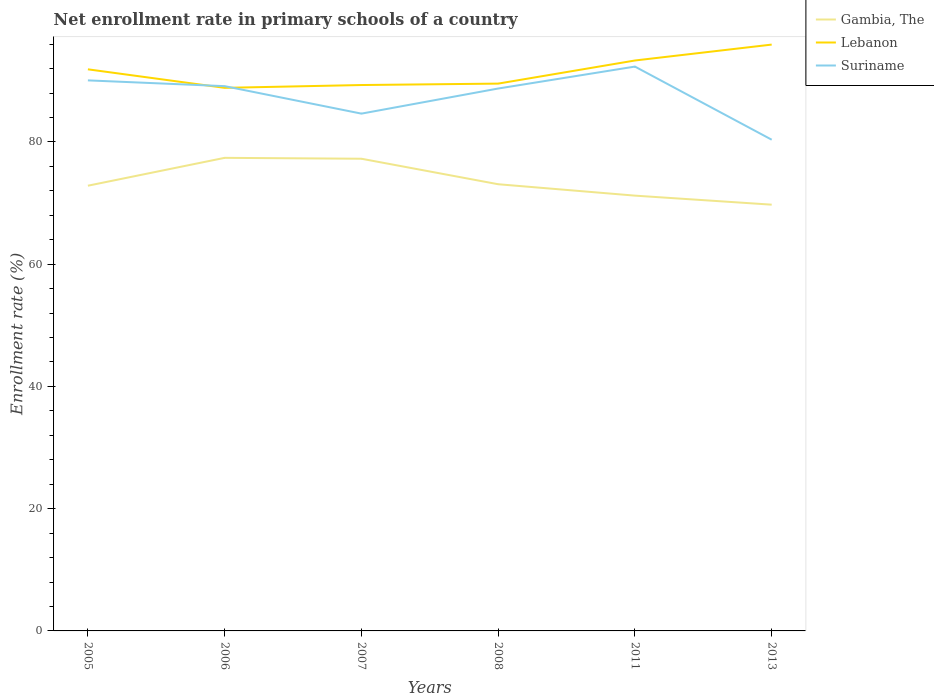Does the line corresponding to Lebanon intersect with the line corresponding to Gambia, The?
Provide a succinct answer. No. Across all years, what is the maximum enrollment rate in primary schools in Gambia, The?
Provide a short and direct response. 69.74. In which year was the enrollment rate in primary schools in Suriname maximum?
Ensure brevity in your answer.  2013. What is the total enrollment rate in primary schools in Lebanon in the graph?
Provide a succinct answer. -0.46. What is the difference between the highest and the second highest enrollment rate in primary schools in Suriname?
Give a very brief answer. 11.96. What is the difference between the highest and the lowest enrollment rate in primary schools in Lebanon?
Provide a short and direct response. 3. Is the enrollment rate in primary schools in Lebanon strictly greater than the enrollment rate in primary schools in Gambia, The over the years?
Give a very brief answer. No. How many lines are there?
Provide a short and direct response. 3. How many years are there in the graph?
Provide a succinct answer. 6. Are the values on the major ticks of Y-axis written in scientific E-notation?
Your answer should be compact. No. Does the graph contain any zero values?
Provide a short and direct response. No. Where does the legend appear in the graph?
Offer a terse response. Top right. How many legend labels are there?
Your answer should be very brief. 3. What is the title of the graph?
Make the answer very short. Net enrollment rate in primary schools of a country. Does "Suriname" appear as one of the legend labels in the graph?
Make the answer very short. Yes. What is the label or title of the X-axis?
Offer a very short reply. Years. What is the label or title of the Y-axis?
Make the answer very short. Enrollment rate (%). What is the Enrollment rate (%) of Gambia, The in 2005?
Offer a very short reply. 72.84. What is the Enrollment rate (%) in Lebanon in 2005?
Your answer should be very brief. 91.88. What is the Enrollment rate (%) of Suriname in 2005?
Provide a short and direct response. 90.07. What is the Enrollment rate (%) in Gambia, The in 2006?
Provide a short and direct response. 77.4. What is the Enrollment rate (%) in Lebanon in 2006?
Your response must be concise. 88.85. What is the Enrollment rate (%) of Suriname in 2006?
Your answer should be compact. 89.13. What is the Enrollment rate (%) in Gambia, The in 2007?
Ensure brevity in your answer.  77.25. What is the Enrollment rate (%) in Lebanon in 2007?
Provide a short and direct response. 89.31. What is the Enrollment rate (%) in Suriname in 2007?
Offer a very short reply. 84.63. What is the Enrollment rate (%) of Gambia, The in 2008?
Ensure brevity in your answer.  73.08. What is the Enrollment rate (%) in Lebanon in 2008?
Your response must be concise. 89.54. What is the Enrollment rate (%) of Suriname in 2008?
Provide a succinct answer. 88.74. What is the Enrollment rate (%) of Gambia, The in 2011?
Offer a terse response. 71.21. What is the Enrollment rate (%) of Lebanon in 2011?
Your response must be concise. 93.32. What is the Enrollment rate (%) in Suriname in 2011?
Make the answer very short. 92.33. What is the Enrollment rate (%) in Gambia, The in 2013?
Keep it short and to the point. 69.74. What is the Enrollment rate (%) of Lebanon in 2013?
Keep it short and to the point. 95.93. What is the Enrollment rate (%) of Suriname in 2013?
Offer a very short reply. 80.36. Across all years, what is the maximum Enrollment rate (%) of Gambia, The?
Offer a very short reply. 77.4. Across all years, what is the maximum Enrollment rate (%) of Lebanon?
Offer a terse response. 95.93. Across all years, what is the maximum Enrollment rate (%) in Suriname?
Ensure brevity in your answer.  92.33. Across all years, what is the minimum Enrollment rate (%) of Gambia, The?
Provide a short and direct response. 69.74. Across all years, what is the minimum Enrollment rate (%) of Lebanon?
Your answer should be compact. 88.85. Across all years, what is the minimum Enrollment rate (%) in Suriname?
Provide a short and direct response. 80.36. What is the total Enrollment rate (%) in Gambia, The in the graph?
Provide a succinct answer. 441.52. What is the total Enrollment rate (%) in Lebanon in the graph?
Offer a very short reply. 548.83. What is the total Enrollment rate (%) of Suriname in the graph?
Offer a very short reply. 525.26. What is the difference between the Enrollment rate (%) in Gambia, The in 2005 and that in 2006?
Offer a very short reply. -4.56. What is the difference between the Enrollment rate (%) of Lebanon in 2005 and that in 2006?
Keep it short and to the point. 3.03. What is the difference between the Enrollment rate (%) of Suriname in 2005 and that in 2006?
Your answer should be very brief. 0.95. What is the difference between the Enrollment rate (%) in Gambia, The in 2005 and that in 2007?
Make the answer very short. -4.41. What is the difference between the Enrollment rate (%) of Lebanon in 2005 and that in 2007?
Provide a short and direct response. 2.57. What is the difference between the Enrollment rate (%) of Suriname in 2005 and that in 2007?
Your response must be concise. 5.44. What is the difference between the Enrollment rate (%) of Gambia, The in 2005 and that in 2008?
Provide a short and direct response. -0.24. What is the difference between the Enrollment rate (%) in Lebanon in 2005 and that in 2008?
Provide a short and direct response. 2.34. What is the difference between the Enrollment rate (%) of Suriname in 2005 and that in 2008?
Your answer should be very brief. 1.33. What is the difference between the Enrollment rate (%) of Gambia, The in 2005 and that in 2011?
Your answer should be very brief. 1.62. What is the difference between the Enrollment rate (%) of Lebanon in 2005 and that in 2011?
Your answer should be very brief. -1.44. What is the difference between the Enrollment rate (%) in Suriname in 2005 and that in 2011?
Keep it short and to the point. -2.26. What is the difference between the Enrollment rate (%) in Gambia, The in 2005 and that in 2013?
Provide a short and direct response. 3.1. What is the difference between the Enrollment rate (%) in Lebanon in 2005 and that in 2013?
Your answer should be very brief. -4.05. What is the difference between the Enrollment rate (%) in Suriname in 2005 and that in 2013?
Offer a terse response. 9.71. What is the difference between the Enrollment rate (%) of Gambia, The in 2006 and that in 2007?
Provide a succinct answer. 0.14. What is the difference between the Enrollment rate (%) of Lebanon in 2006 and that in 2007?
Your answer should be very brief. -0.46. What is the difference between the Enrollment rate (%) in Suriname in 2006 and that in 2007?
Provide a short and direct response. 4.49. What is the difference between the Enrollment rate (%) in Gambia, The in 2006 and that in 2008?
Keep it short and to the point. 4.32. What is the difference between the Enrollment rate (%) of Lebanon in 2006 and that in 2008?
Your answer should be very brief. -0.69. What is the difference between the Enrollment rate (%) of Suriname in 2006 and that in 2008?
Make the answer very short. 0.39. What is the difference between the Enrollment rate (%) of Gambia, The in 2006 and that in 2011?
Give a very brief answer. 6.18. What is the difference between the Enrollment rate (%) of Lebanon in 2006 and that in 2011?
Keep it short and to the point. -4.47. What is the difference between the Enrollment rate (%) in Suriname in 2006 and that in 2011?
Your answer should be very brief. -3.2. What is the difference between the Enrollment rate (%) in Gambia, The in 2006 and that in 2013?
Provide a short and direct response. 7.66. What is the difference between the Enrollment rate (%) of Lebanon in 2006 and that in 2013?
Make the answer very short. -7.08. What is the difference between the Enrollment rate (%) of Suriname in 2006 and that in 2013?
Keep it short and to the point. 8.76. What is the difference between the Enrollment rate (%) in Gambia, The in 2007 and that in 2008?
Give a very brief answer. 4.17. What is the difference between the Enrollment rate (%) of Lebanon in 2007 and that in 2008?
Keep it short and to the point. -0.23. What is the difference between the Enrollment rate (%) of Suriname in 2007 and that in 2008?
Give a very brief answer. -4.11. What is the difference between the Enrollment rate (%) in Gambia, The in 2007 and that in 2011?
Make the answer very short. 6.04. What is the difference between the Enrollment rate (%) in Lebanon in 2007 and that in 2011?
Offer a terse response. -4.01. What is the difference between the Enrollment rate (%) of Suriname in 2007 and that in 2011?
Offer a terse response. -7.7. What is the difference between the Enrollment rate (%) of Gambia, The in 2007 and that in 2013?
Give a very brief answer. 7.52. What is the difference between the Enrollment rate (%) in Lebanon in 2007 and that in 2013?
Your response must be concise. -6.62. What is the difference between the Enrollment rate (%) in Suriname in 2007 and that in 2013?
Make the answer very short. 4.27. What is the difference between the Enrollment rate (%) of Gambia, The in 2008 and that in 2011?
Provide a succinct answer. 1.86. What is the difference between the Enrollment rate (%) in Lebanon in 2008 and that in 2011?
Make the answer very short. -3.78. What is the difference between the Enrollment rate (%) of Suriname in 2008 and that in 2011?
Your answer should be very brief. -3.59. What is the difference between the Enrollment rate (%) in Gambia, The in 2008 and that in 2013?
Provide a short and direct response. 3.34. What is the difference between the Enrollment rate (%) of Lebanon in 2008 and that in 2013?
Your answer should be compact. -6.39. What is the difference between the Enrollment rate (%) of Suriname in 2008 and that in 2013?
Provide a succinct answer. 8.37. What is the difference between the Enrollment rate (%) in Gambia, The in 2011 and that in 2013?
Your response must be concise. 1.48. What is the difference between the Enrollment rate (%) in Lebanon in 2011 and that in 2013?
Give a very brief answer. -2.6. What is the difference between the Enrollment rate (%) of Suriname in 2011 and that in 2013?
Ensure brevity in your answer.  11.96. What is the difference between the Enrollment rate (%) of Gambia, The in 2005 and the Enrollment rate (%) of Lebanon in 2006?
Offer a terse response. -16.01. What is the difference between the Enrollment rate (%) of Gambia, The in 2005 and the Enrollment rate (%) of Suriname in 2006?
Give a very brief answer. -16.29. What is the difference between the Enrollment rate (%) of Lebanon in 2005 and the Enrollment rate (%) of Suriname in 2006?
Provide a short and direct response. 2.75. What is the difference between the Enrollment rate (%) of Gambia, The in 2005 and the Enrollment rate (%) of Lebanon in 2007?
Your answer should be very brief. -16.47. What is the difference between the Enrollment rate (%) of Gambia, The in 2005 and the Enrollment rate (%) of Suriname in 2007?
Your answer should be very brief. -11.79. What is the difference between the Enrollment rate (%) in Lebanon in 2005 and the Enrollment rate (%) in Suriname in 2007?
Offer a terse response. 7.25. What is the difference between the Enrollment rate (%) in Gambia, The in 2005 and the Enrollment rate (%) in Lebanon in 2008?
Your answer should be very brief. -16.7. What is the difference between the Enrollment rate (%) of Gambia, The in 2005 and the Enrollment rate (%) of Suriname in 2008?
Ensure brevity in your answer.  -15.9. What is the difference between the Enrollment rate (%) in Lebanon in 2005 and the Enrollment rate (%) in Suriname in 2008?
Make the answer very short. 3.14. What is the difference between the Enrollment rate (%) in Gambia, The in 2005 and the Enrollment rate (%) in Lebanon in 2011?
Give a very brief answer. -20.48. What is the difference between the Enrollment rate (%) in Gambia, The in 2005 and the Enrollment rate (%) in Suriname in 2011?
Provide a short and direct response. -19.49. What is the difference between the Enrollment rate (%) in Lebanon in 2005 and the Enrollment rate (%) in Suriname in 2011?
Give a very brief answer. -0.45. What is the difference between the Enrollment rate (%) of Gambia, The in 2005 and the Enrollment rate (%) of Lebanon in 2013?
Offer a very short reply. -23.09. What is the difference between the Enrollment rate (%) in Gambia, The in 2005 and the Enrollment rate (%) in Suriname in 2013?
Provide a short and direct response. -7.53. What is the difference between the Enrollment rate (%) of Lebanon in 2005 and the Enrollment rate (%) of Suriname in 2013?
Offer a very short reply. 11.52. What is the difference between the Enrollment rate (%) of Gambia, The in 2006 and the Enrollment rate (%) of Lebanon in 2007?
Provide a short and direct response. -11.91. What is the difference between the Enrollment rate (%) in Gambia, The in 2006 and the Enrollment rate (%) in Suriname in 2007?
Your answer should be compact. -7.23. What is the difference between the Enrollment rate (%) of Lebanon in 2006 and the Enrollment rate (%) of Suriname in 2007?
Your answer should be very brief. 4.22. What is the difference between the Enrollment rate (%) in Gambia, The in 2006 and the Enrollment rate (%) in Lebanon in 2008?
Your response must be concise. -12.15. What is the difference between the Enrollment rate (%) of Gambia, The in 2006 and the Enrollment rate (%) of Suriname in 2008?
Offer a terse response. -11.34. What is the difference between the Enrollment rate (%) in Lebanon in 2006 and the Enrollment rate (%) in Suriname in 2008?
Your response must be concise. 0.11. What is the difference between the Enrollment rate (%) of Gambia, The in 2006 and the Enrollment rate (%) of Lebanon in 2011?
Give a very brief answer. -15.93. What is the difference between the Enrollment rate (%) in Gambia, The in 2006 and the Enrollment rate (%) in Suriname in 2011?
Give a very brief answer. -14.93. What is the difference between the Enrollment rate (%) in Lebanon in 2006 and the Enrollment rate (%) in Suriname in 2011?
Make the answer very short. -3.48. What is the difference between the Enrollment rate (%) of Gambia, The in 2006 and the Enrollment rate (%) of Lebanon in 2013?
Your answer should be compact. -18.53. What is the difference between the Enrollment rate (%) in Gambia, The in 2006 and the Enrollment rate (%) in Suriname in 2013?
Offer a terse response. -2.97. What is the difference between the Enrollment rate (%) in Lebanon in 2006 and the Enrollment rate (%) in Suriname in 2013?
Your answer should be compact. 8.48. What is the difference between the Enrollment rate (%) in Gambia, The in 2007 and the Enrollment rate (%) in Lebanon in 2008?
Offer a terse response. -12.29. What is the difference between the Enrollment rate (%) in Gambia, The in 2007 and the Enrollment rate (%) in Suriname in 2008?
Offer a terse response. -11.49. What is the difference between the Enrollment rate (%) in Lebanon in 2007 and the Enrollment rate (%) in Suriname in 2008?
Your answer should be very brief. 0.57. What is the difference between the Enrollment rate (%) in Gambia, The in 2007 and the Enrollment rate (%) in Lebanon in 2011?
Provide a succinct answer. -16.07. What is the difference between the Enrollment rate (%) of Gambia, The in 2007 and the Enrollment rate (%) of Suriname in 2011?
Make the answer very short. -15.08. What is the difference between the Enrollment rate (%) in Lebanon in 2007 and the Enrollment rate (%) in Suriname in 2011?
Provide a succinct answer. -3.02. What is the difference between the Enrollment rate (%) of Gambia, The in 2007 and the Enrollment rate (%) of Lebanon in 2013?
Make the answer very short. -18.68. What is the difference between the Enrollment rate (%) of Gambia, The in 2007 and the Enrollment rate (%) of Suriname in 2013?
Your answer should be very brief. -3.11. What is the difference between the Enrollment rate (%) in Lebanon in 2007 and the Enrollment rate (%) in Suriname in 2013?
Make the answer very short. 8.94. What is the difference between the Enrollment rate (%) in Gambia, The in 2008 and the Enrollment rate (%) in Lebanon in 2011?
Provide a succinct answer. -20.24. What is the difference between the Enrollment rate (%) of Gambia, The in 2008 and the Enrollment rate (%) of Suriname in 2011?
Provide a short and direct response. -19.25. What is the difference between the Enrollment rate (%) of Lebanon in 2008 and the Enrollment rate (%) of Suriname in 2011?
Offer a very short reply. -2.79. What is the difference between the Enrollment rate (%) of Gambia, The in 2008 and the Enrollment rate (%) of Lebanon in 2013?
Your response must be concise. -22.85. What is the difference between the Enrollment rate (%) in Gambia, The in 2008 and the Enrollment rate (%) in Suriname in 2013?
Ensure brevity in your answer.  -7.29. What is the difference between the Enrollment rate (%) of Lebanon in 2008 and the Enrollment rate (%) of Suriname in 2013?
Make the answer very short. 9.18. What is the difference between the Enrollment rate (%) of Gambia, The in 2011 and the Enrollment rate (%) of Lebanon in 2013?
Ensure brevity in your answer.  -24.71. What is the difference between the Enrollment rate (%) in Gambia, The in 2011 and the Enrollment rate (%) in Suriname in 2013?
Your answer should be compact. -9.15. What is the difference between the Enrollment rate (%) of Lebanon in 2011 and the Enrollment rate (%) of Suriname in 2013?
Give a very brief answer. 12.96. What is the average Enrollment rate (%) in Gambia, The per year?
Keep it short and to the point. 73.59. What is the average Enrollment rate (%) of Lebanon per year?
Make the answer very short. 91.47. What is the average Enrollment rate (%) of Suriname per year?
Your answer should be compact. 87.54. In the year 2005, what is the difference between the Enrollment rate (%) of Gambia, The and Enrollment rate (%) of Lebanon?
Provide a short and direct response. -19.04. In the year 2005, what is the difference between the Enrollment rate (%) of Gambia, The and Enrollment rate (%) of Suriname?
Keep it short and to the point. -17.23. In the year 2005, what is the difference between the Enrollment rate (%) in Lebanon and Enrollment rate (%) in Suriname?
Your response must be concise. 1.81. In the year 2006, what is the difference between the Enrollment rate (%) of Gambia, The and Enrollment rate (%) of Lebanon?
Offer a very short reply. -11.45. In the year 2006, what is the difference between the Enrollment rate (%) of Gambia, The and Enrollment rate (%) of Suriname?
Provide a succinct answer. -11.73. In the year 2006, what is the difference between the Enrollment rate (%) in Lebanon and Enrollment rate (%) in Suriname?
Your answer should be very brief. -0.28. In the year 2007, what is the difference between the Enrollment rate (%) of Gambia, The and Enrollment rate (%) of Lebanon?
Your answer should be very brief. -12.06. In the year 2007, what is the difference between the Enrollment rate (%) of Gambia, The and Enrollment rate (%) of Suriname?
Provide a short and direct response. -7.38. In the year 2007, what is the difference between the Enrollment rate (%) in Lebanon and Enrollment rate (%) in Suriname?
Your answer should be compact. 4.68. In the year 2008, what is the difference between the Enrollment rate (%) of Gambia, The and Enrollment rate (%) of Lebanon?
Keep it short and to the point. -16.46. In the year 2008, what is the difference between the Enrollment rate (%) of Gambia, The and Enrollment rate (%) of Suriname?
Provide a succinct answer. -15.66. In the year 2008, what is the difference between the Enrollment rate (%) of Lebanon and Enrollment rate (%) of Suriname?
Offer a terse response. 0.8. In the year 2011, what is the difference between the Enrollment rate (%) in Gambia, The and Enrollment rate (%) in Lebanon?
Offer a very short reply. -22.11. In the year 2011, what is the difference between the Enrollment rate (%) in Gambia, The and Enrollment rate (%) in Suriname?
Your answer should be compact. -21.11. In the year 2011, what is the difference between the Enrollment rate (%) of Lebanon and Enrollment rate (%) of Suriname?
Ensure brevity in your answer.  1. In the year 2013, what is the difference between the Enrollment rate (%) of Gambia, The and Enrollment rate (%) of Lebanon?
Provide a short and direct response. -26.19. In the year 2013, what is the difference between the Enrollment rate (%) in Gambia, The and Enrollment rate (%) in Suriname?
Provide a succinct answer. -10.63. In the year 2013, what is the difference between the Enrollment rate (%) in Lebanon and Enrollment rate (%) in Suriname?
Give a very brief answer. 15.56. What is the ratio of the Enrollment rate (%) in Gambia, The in 2005 to that in 2006?
Provide a short and direct response. 0.94. What is the ratio of the Enrollment rate (%) of Lebanon in 2005 to that in 2006?
Provide a short and direct response. 1.03. What is the ratio of the Enrollment rate (%) of Suriname in 2005 to that in 2006?
Ensure brevity in your answer.  1.01. What is the ratio of the Enrollment rate (%) of Gambia, The in 2005 to that in 2007?
Provide a succinct answer. 0.94. What is the ratio of the Enrollment rate (%) in Lebanon in 2005 to that in 2007?
Give a very brief answer. 1.03. What is the ratio of the Enrollment rate (%) of Suriname in 2005 to that in 2007?
Your answer should be very brief. 1.06. What is the ratio of the Enrollment rate (%) of Lebanon in 2005 to that in 2008?
Your answer should be very brief. 1.03. What is the ratio of the Enrollment rate (%) in Suriname in 2005 to that in 2008?
Make the answer very short. 1.01. What is the ratio of the Enrollment rate (%) of Gambia, The in 2005 to that in 2011?
Provide a short and direct response. 1.02. What is the ratio of the Enrollment rate (%) of Lebanon in 2005 to that in 2011?
Keep it short and to the point. 0.98. What is the ratio of the Enrollment rate (%) in Suriname in 2005 to that in 2011?
Make the answer very short. 0.98. What is the ratio of the Enrollment rate (%) in Gambia, The in 2005 to that in 2013?
Keep it short and to the point. 1.04. What is the ratio of the Enrollment rate (%) of Lebanon in 2005 to that in 2013?
Give a very brief answer. 0.96. What is the ratio of the Enrollment rate (%) in Suriname in 2005 to that in 2013?
Your response must be concise. 1.12. What is the ratio of the Enrollment rate (%) of Gambia, The in 2006 to that in 2007?
Provide a short and direct response. 1. What is the ratio of the Enrollment rate (%) in Suriname in 2006 to that in 2007?
Give a very brief answer. 1.05. What is the ratio of the Enrollment rate (%) in Gambia, The in 2006 to that in 2008?
Your response must be concise. 1.06. What is the ratio of the Enrollment rate (%) of Lebanon in 2006 to that in 2008?
Keep it short and to the point. 0.99. What is the ratio of the Enrollment rate (%) in Gambia, The in 2006 to that in 2011?
Make the answer very short. 1.09. What is the ratio of the Enrollment rate (%) in Lebanon in 2006 to that in 2011?
Give a very brief answer. 0.95. What is the ratio of the Enrollment rate (%) of Suriname in 2006 to that in 2011?
Make the answer very short. 0.97. What is the ratio of the Enrollment rate (%) in Gambia, The in 2006 to that in 2013?
Ensure brevity in your answer.  1.11. What is the ratio of the Enrollment rate (%) of Lebanon in 2006 to that in 2013?
Ensure brevity in your answer.  0.93. What is the ratio of the Enrollment rate (%) of Suriname in 2006 to that in 2013?
Provide a short and direct response. 1.11. What is the ratio of the Enrollment rate (%) of Gambia, The in 2007 to that in 2008?
Offer a very short reply. 1.06. What is the ratio of the Enrollment rate (%) in Lebanon in 2007 to that in 2008?
Provide a succinct answer. 1. What is the ratio of the Enrollment rate (%) in Suriname in 2007 to that in 2008?
Your response must be concise. 0.95. What is the ratio of the Enrollment rate (%) in Gambia, The in 2007 to that in 2011?
Ensure brevity in your answer.  1.08. What is the ratio of the Enrollment rate (%) in Lebanon in 2007 to that in 2011?
Ensure brevity in your answer.  0.96. What is the ratio of the Enrollment rate (%) in Suriname in 2007 to that in 2011?
Provide a short and direct response. 0.92. What is the ratio of the Enrollment rate (%) of Gambia, The in 2007 to that in 2013?
Provide a short and direct response. 1.11. What is the ratio of the Enrollment rate (%) of Suriname in 2007 to that in 2013?
Offer a very short reply. 1.05. What is the ratio of the Enrollment rate (%) of Gambia, The in 2008 to that in 2011?
Your answer should be compact. 1.03. What is the ratio of the Enrollment rate (%) in Lebanon in 2008 to that in 2011?
Your answer should be very brief. 0.96. What is the ratio of the Enrollment rate (%) in Suriname in 2008 to that in 2011?
Your answer should be very brief. 0.96. What is the ratio of the Enrollment rate (%) of Gambia, The in 2008 to that in 2013?
Ensure brevity in your answer.  1.05. What is the ratio of the Enrollment rate (%) in Lebanon in 2008 to that in 2013?
Your response must be concise. 0.93. What is the ratio of the Enrollment rate (%) of Suriname in 2008 to that in 2013?
Your answer should be compact. 1.1. What is the ratio of the Enrollment rate (%) of Gambia, The in 2011 to that in 2013?
Offer a very short reply. 1.02. What is the ratio of the Enrollment rate (%) in Lebanon in 2011 to that in 2013?
Keep it short and to the point. 0.97. What is the ratio of the Enrollment rate (%) in Suriname in 2011 to that in 2013?
Make the answer very short. 1.15. What is the difference between the highest and the second highest Enrollment rate (%) in Gambia, The?
Ensure brevity in your answer.  0.14. What is the difference between the highest and the second highest Enrollment rate (%) of Lebanon?
Offer a terse response. 2.6. What is the difference between the highest and the second highest Enrollment rate (%) of Suriname?
Give a very brief answer. 2.26. What is the difference between the highest and the lowest Enrollment rate (%) in Gambia, The?
Provide a short and direct response. 7.66. What is the difference between the highest and the lowest Enrollment rate (%) in Lebanon?
Ensure brevity in your answer.  7.08. What is the difference between the highest and the lowest Enrollment rate (%) in Suriname?
Ensure brevity in your answer.  11.96. 